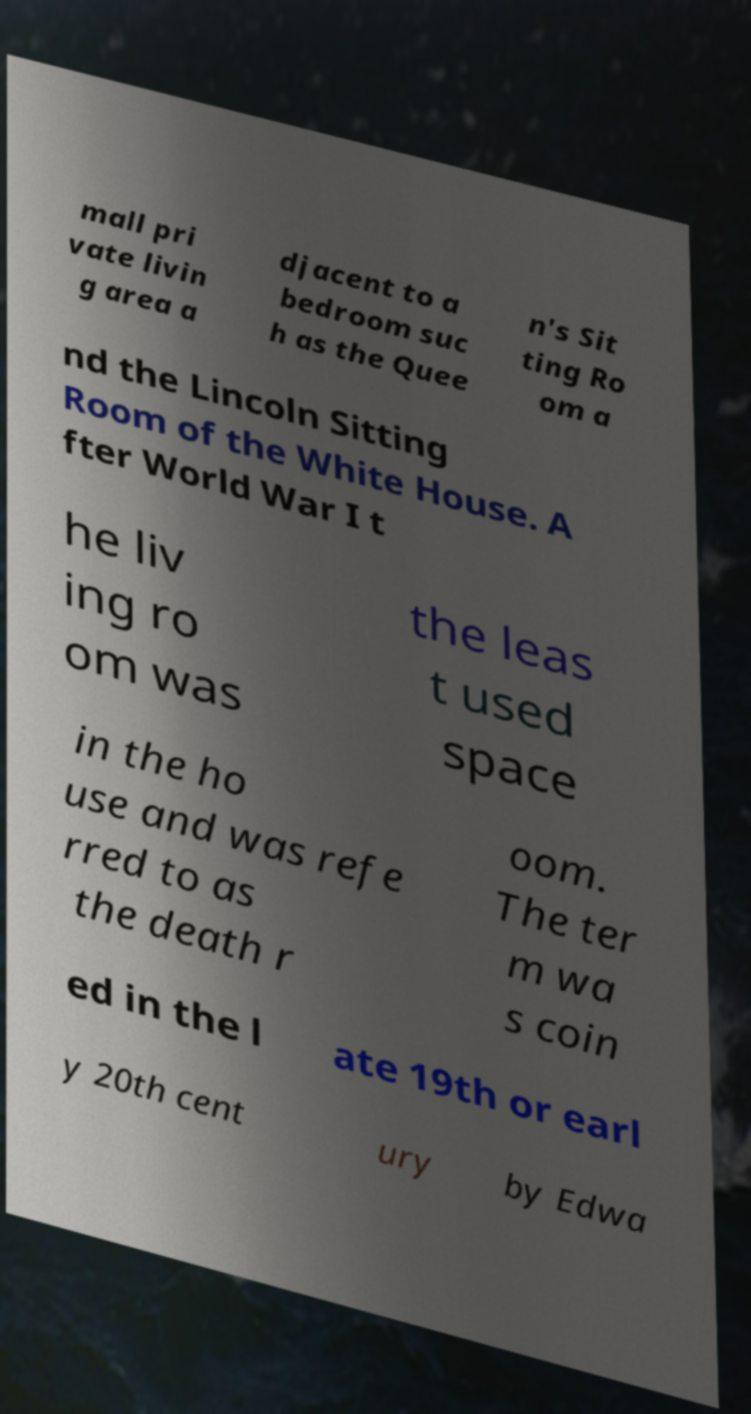For documentation purposes, I need the text within this image transcribed. Could you provide that? mall pri vate livin g area a djacent to a bedroom suc h as the Quee n's Sit ting Ro om a nd the Lincoln Sitting Room of the White House. A fter World War I t he liv ing ro om was the leas t used space in the ho use and was refe rred to as the death r oom. The ter m wa s coin ed in the l ate 19th or earl y 20th cent ury by Edwa 